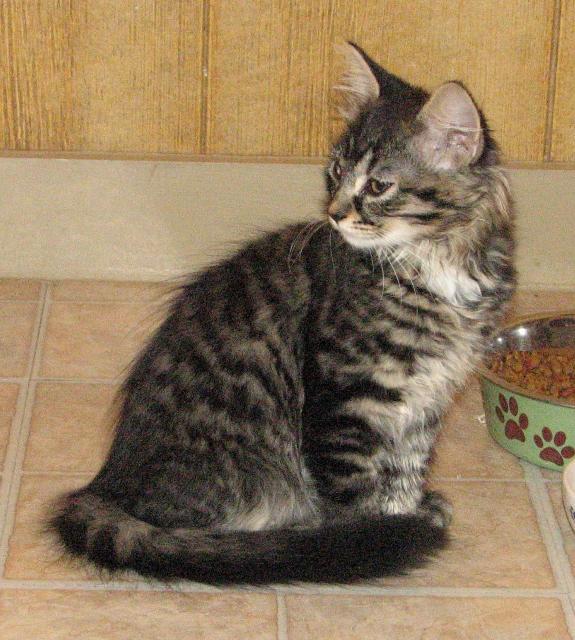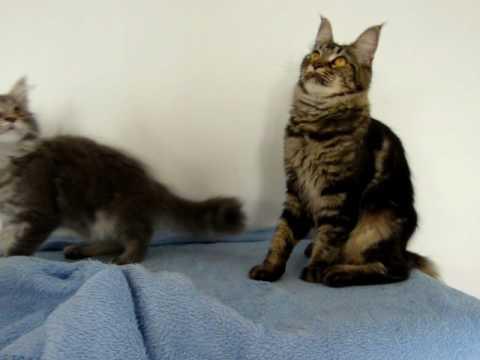The first image is the image on the left, the second image is the image on the right. Examine the images to the left and right. Is the description "The left image shows a cat with open eyes reclining on soft furniture with pillows." accurate? Answer yes or no. No. The first image is the image on the left, the second image is the image on the right. Examine the images to the left and right. Is the description "The left and right image contains the same number of kittens." accurate? Answer yes or no. No. 